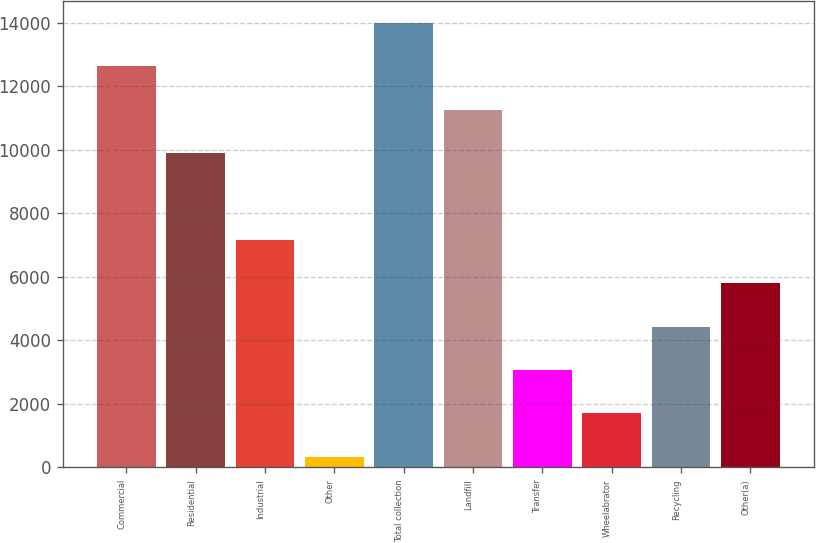Convert chart to OTSL. <chart><loc_0><loc_0><loc_500><loc_500><bar_chart><fcel>Commercial<fcel>Residential<fcel>Industrial<fcel>Other<fcel>Total collection<fcel>Landfill<fcel>Transfer<fcel>Wheelabrator<fcel>Recycling<fcel>Other(a)<nl><fcel>12630.4<fcel>9899.2<fcel>7168<fcel>340<fcel>13996<fcel>11264.8<fcel>3071.2<fcel>1705.6<fcel>4436.8<fcel>5802.4<nl></chart> 